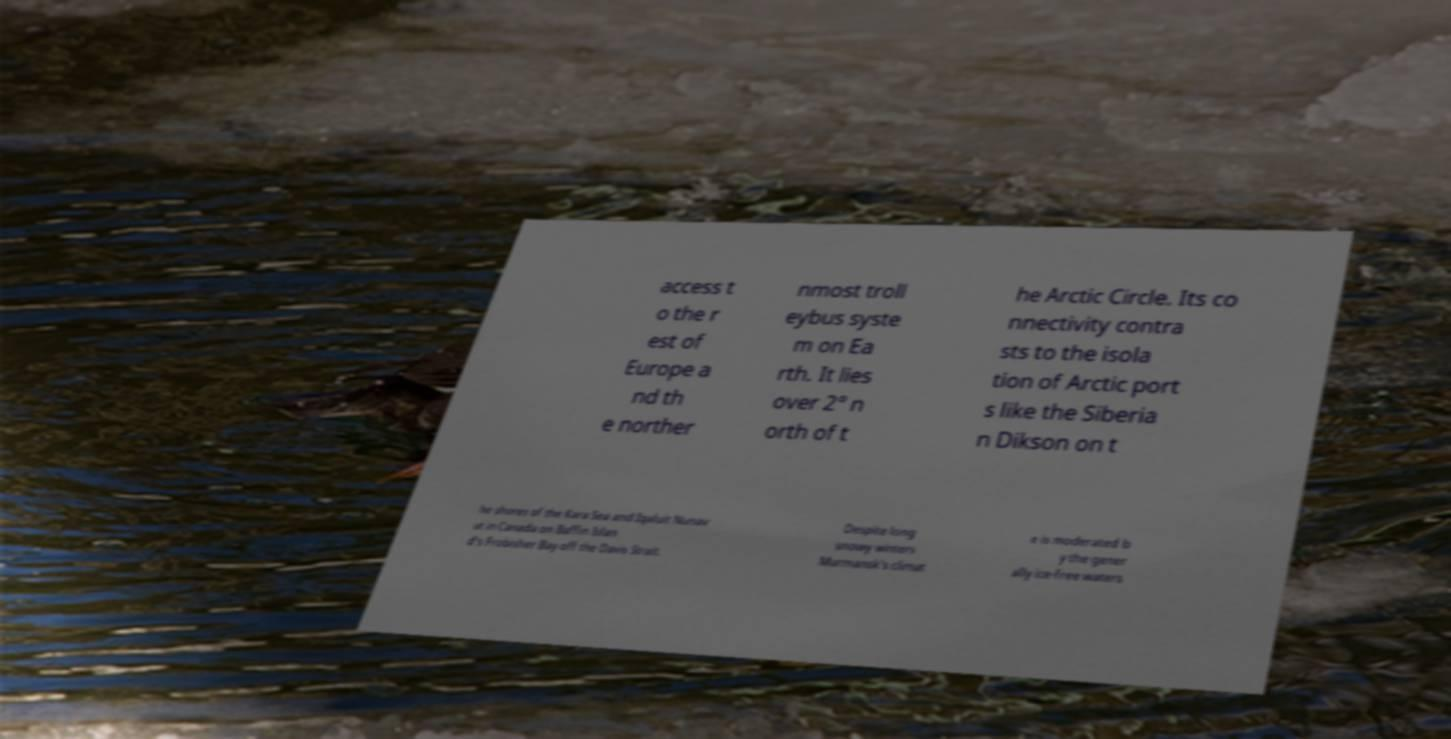I need the written content from this picture converted into text. Can you do that? access t o the r est of Europe a nd th e norther nmost troll eybus syste m on Ea rth. It lies over 2° n orth of t he Arctic Circle. Its co nnectivity contra sts to the isola tion of Arctic port s like the Siberia n Dikson on t he shores of the Kara Sea and Iqaluit Nunav ut in Canada on Baffin Islan d's Frobisher Bay off the Davis Strait. Despite long snowy winters Murmansk's climat e is moderated b y the gener ally ice-free waters 